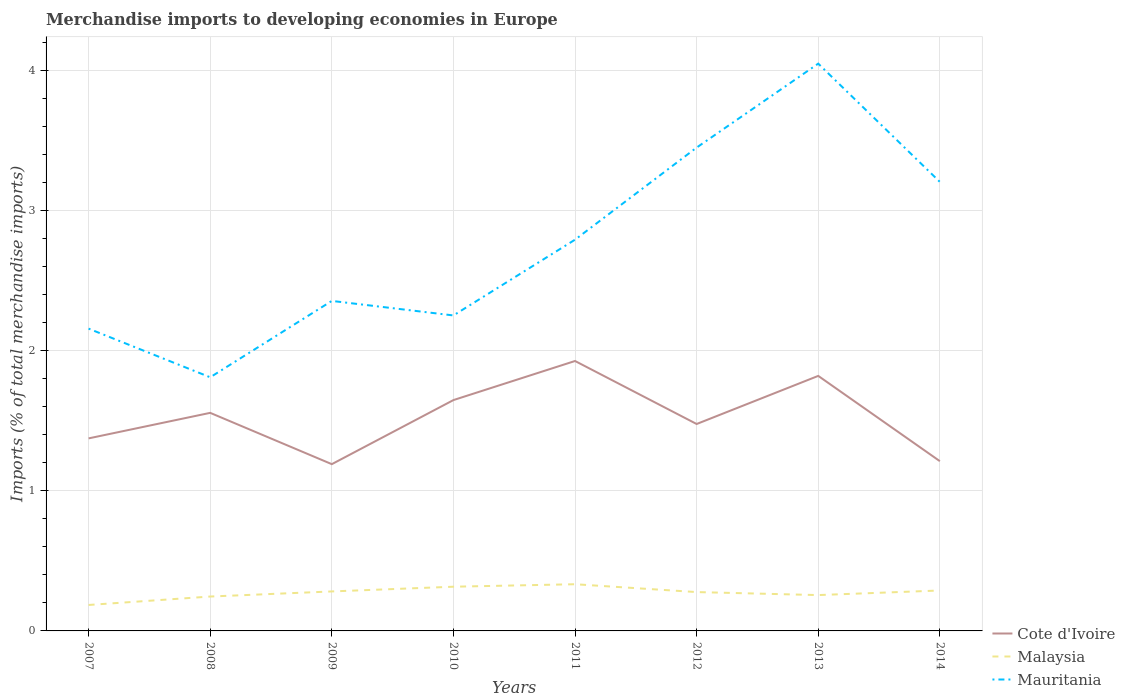Does the line corresponding to Mauritania intersect with the line corresponding to Malaysia?
Give a very brief answer. No. Across all years, what is the maximum percentage total merchandise imports in Cote d'Ivoire?
Offer a terse response. 1.19. What is the total percentage total merchandise imports in Malaysia in the graph?
Keep it short and to the point. -0.02. What is the difference between the highest and the second highest percentage total merchandise imports in Cote d'Ivoire?
Your answer should be compact. 0.74. What is the difference between the highest and the lowest percentage total merchandise imports in Cote d'Ivoire?
Keep it short and to the point. 4. How many lines are there?
Keep it short and to the point. 3. What is the difference between two consecutive major ticks on the Y-axis?
Offer a very short reply. 1. Where does the legend appear in the graph?
Ensure brevity in your answer.  Bottom right. What is the title of the graph?
Give a very brief answer. Merchandise imports to developing economies in Europe. What is the label or title of the X-axis?
Keep it short and to the point. Years. What is the label or title of the Y-axis?
Keep it short and to the point. Imports (% of total merchandise imports). What is the Imports (% of total merchandise imports) in Cote d'Ivoire in 2007?
Ensure brevity in your answer.  1.37. What is the Imports (% of total merchandise imports) in Malaysia in 2007?
Offer a terse response. 0.19. What is the Imports (% of total merchandise imports) in Mauritania in 2007?
Provide a succinct answer. 2.16. What is the Imports (% of total merchandise imports) in Cote d'Ivoire in 2008?
Your answer should be very brief. 1.56. What is the Imports (% of total merchandise imports) of Malaysia in 2008?
Give a very brief answer. 0.25. What is the Imports (% of total merchandise imports) of Mauritania in 2008?
Ensure brevity in your answer.  1.81. What is the Imports (% of total merchandise imports) of Cote d'Ivoire in 2009?
Make the answer very short. 1.19. What is the Imports (% of total merchandise imports) in Malaysia in 2009?
Provide a succinct answer. 0.28. What is the Imports (% of total merchandise imports) of Mauritania in 2009?
Your response must be concise. 2.36. What is the Imports (% of total merchandise imports) in Cote d'Ivoire in 2010?
Offer a very short reply. 1.65. What is the Imports (% of total merchandise imports) of Malaysia in 2010?
Offer a terse response. 0.32. What is the Imports (% of total merchandise imports) in Mauritania in 2010?
Your answer should be compact. 2.25. What is the Imports (% of total merchandise imports) in Cote d'Ivoire in 2011?
Your answer should be compact. 1.93. What is the Imports (% of total merchandise imports) in Malaysia in 2011?
Make the answer very short. 0.33. What is the Imports (% of total merchandise imports) in Mauritania in 2011?
Your answer should be very brief. 2.79. What is the Imports (% of total merchandise imports) in Cote d'Ivoire in 2012?
Keep it short and to the point. 1.48. What is the Imports (% of total merchandise imports) of Malaysia in 2012?
Provide a succinct answer. 0.28. What is the Imports (% of total merchandise imports) of Mauritania in 2012?
Your answer should be compact. 3.45. What is the Imports (% of total merchandise imports) in Cote d'Ivoire in 2013?
Make the answer very short. 1.82. What is the Imports (% of total merchandise imports) in Malaysia in 2013?
Provide a short and direct response. 0.26. What is the Imports (% of total merchandise imports) in Mauritania in 2013?
Your answer should be compact. 4.05. What is the Imports (% of total merchandise imports) of Cote d'Ivoire in 2014?
Your answer should be very brief. 1.21. What is the Imports (% of total merchandise imports) in Malaysia in 2014?
Ensure brevity in your answer.  0.29. What is the Imports (% of total merchandise imports) of Mauritania in 2014?
Your answer should be very brief. 3.21. Across all years, what is the maximum Imports (% of total merchandise imports) in Cote d'Ivoire?
Provide a succinct answer. 1.93. Across all years, what is the maximum Imports (% of total merchandise imports) in Malaysia?
Your answer should be very brief. 0.33. Across all years, what is the maximum Imports (% of total merchandise imports) of Mauritania?
Your response must be concise. 4.05. Across all years, what is the minimum Imports (% of total merchandise imports) of Cote d'Ivoire?
Offer a terse response. 1.19. Across all years, what is the minimum Imports (% of total merchandise imports) in Malaysia?
Your answer should be very brief. 0.19. Across all years, what is the minimum Imports (% of total merchandise imports) in Mauritania?
Your answer should be very brief. 1.81. What is the total Imports (% of total merchandise imports) in Cote d'Ivoire in the graph?
Your answer should be compact. 12.21. What is the total Imports (% of total merchandise imports) of Malaysia in the graph?
Your answer should be very brief. 2.18. What is the total Imports (% of total merchandise imports) in Mauritania in the graph?
Keep it short and to the point. 22.08. What is the difference between the Imports (% of total merchandise imports) of Cote d'Ivoire in 2007 and that in 2008?
Provide a short and direct response. -0.18. What is the difference between the Imports (% of total merchandise imports) of Malaysia in 2007 and that in 2008?
Your answer should be very brief. -0.06. What is the difference between the Imports (% of total merchandise imports) of Mauritania in 2007 and that in 2008?
Provide a short and direct response. 0.35. What is the difference between the Imports (% of total merchandise imports) in Cote d'Ivoire in 2007 and that in 2009?
Provide a succinct answer. 0.18. What is the difference between the Imports (% of total merchandise imports) in Malaysia in 2007 and that in 2009?
Make the answer very short. -0.1. What is the difference between the Imports (% of total merchandise imports) in Mauritania in 2007 and that in 2009?
Ensure brevity in your answer.  -0.2. What is the difference between the Imports (% of total merchandise imports) of Cote d'Ivoire in 2007 and that in 2010?
Give a very brief answer. -0.27. What is the difference between the Imports (% of total merchandise imports) of Malaysia in 2007 and that in 2010?
Offer a terse response. -0.13. What is the difference between the Imports (% of total merchandise imports) in Mauritania in 2007 and that in 2010?
Provide a succinct answer. -0.09. What is the difference between the Imports (% of total merchandise imports) in Cote d'Ivoire in 2007 and that in 2011?
Your answer should be very brief. -0.55. What is the difference between the Imports (% of total merchandise imports) in Malaysia in 2007 and that in 2011?
Give a very brief answer. -0.15. What is the difference between the Imports (% of total merchandise imports) of Mauritania in 2007 and that in 2011?
Your answer should be very brief. -0.64. What is the difference between the Imports (% of total merchandise imports) of Cote d'Ivoire in 2007 and that in 2012?
Offer a terse response. -0.1. What is the difference between the Imports (% of total merchandise imports) of Malaysia in 2007 and that in 2012?
Give a very brief answer. -0.09. What is the difference between the Imports (% of total merchandise imports) in Mauritania in 2007 and that in 2012?
Offer a very short reply. -1.29. What is the difference between the Imports (% of total merchandise imports) of Cote d'Ivoire in 2007 and that in 2013?
Give a very brief answer. -0.45. What is the difference between the Imports (% of total merchandise imports) in Malaysia in 2007 and that in 2013?
Keep it short and to the point. -0.07. What is the difference between the Imports (% of total merchandise imports) of Mauritania in 2007 and that in 2013?
Make the answer very short. -1.89. What is the difference between the Imports (% of total merchandise imports) of Cote d'Ivoire in 2007 and that in 2014?
Ensure brevity in your answer.  0.16. What is the difference between the Imports (% of total merchandise imports) in Malaysia in 2007 and that in 2014?
Ensure brevity in your answer.  -0.1. What is the difference between the Imports (% of total merchandise imports) of Mauritania in 2007 and that in 2014?
Offer a terse response. -1.05. What is the difference between the Imports (% of total merchandise imports) of Cote d'Ivoire in 2008 and that in 2009?
Ensure brevity in your answer.  0.37. What is the difference between the Imports (% of total merchandise imports) in Malaysia in 2008 and that in 2009?
Your answer should be compact. -0.04. What is the difference between the Imports (% of total merchandise imports) of Mauritania in 2008 and that in 2009?
Make the answer very short. -0.55. What is the difference between the Imports (% of total merchandise imports) in Cote d'Ivoire in 2008 and that in 2010?
Your response must be concise. -0.09. What is the difference between the Imports (% of total merchandise imports) in Malaysia in 2008 and that in 2010?
Make the answer very short. -0.07. What is the difference between the Imports (% of total merchandise imports) of Mauritania in 2008 and that in 2010?
Offer a very short reply. -0.44. What is the difference between the Imports (% of total merchandise imports) of Cote d'Ivoire in 2008 and that in 2011?
Offer a terse response. -0.37. What is the difference between the Imports (% of total merchandise imports) in Malaysia in 2008 and that in 2011?
Ensure brevity in your answer.  -0.09. What is the difference between the Imports (% of total merchandise imports) in Mauritania in 2008 and that in 2011?
Make the answer very short. -0.98. What is the difference between the Imports (% of total merchandise imports) in Cote d'Ivoire in 2008 and that in 2012?
Keep it short and to the point. 0.08. What is the difference between the Imports (% of total merchandise imports) of Malaysia in 2008 and that in 2012?
Your response must be concise. -0.03. What is the difference between the Imports (% of total merchandise imports) in Mauritania in 2008 and that in 2012?
Your answer should be very brief. -1.64. What is the difference between the Imports (% of total merchandise imports) of Cote d'Ivoire in 2008 and that in 2013?
Provide a succinct answer. -0.26. What is the difference between the Imports (% of total merchandise imports) in Malaysia in 2008 and that in 2013?
Make the answer very short. -0.01. What is the difference between the Imports (% of total merchandise imports) of Mauritania in 2008 and that in 2013?
Provide a succinct answer. -2.24. What is the difference between the Imports (% of total merchandise imports) in Cote d'Ivoire in 2008 and that in 2014?
Your answer should be very brief. 0.34. What is the difference between the Imports (% of total merchandise imports) in Malaysia in 2008 and that in 2014?
Make the answer very short. -0.04. What is the difference between the Imports (% of total merchandise imports) of Mauritania in 2008 and that in 2014?
Provide a short and direct response. -1.4. What is the difference between the Imports (% of total merchandise imports) of Cote d'Ivoire in 2009 and that in 2010?
Your answer should be very brief. -0.46. What is the difference between the Imports (% of total merchandise imports) in Malaysia in 2009 and that in 2010?
Offer a terse response. -0.03. What is the difference between the Imports (% of total merchandise imports) in Mauritania in 2009 and that in 2010?
Offer a very short reply. 0.1. What is the difference between the Imports (% of total merchandise imports) of Cote d'Ivoire in 2009 and that in 2011?
Offer a terse response. -0.74. What is the difference between the Imports (% of total merchandise imports) of Malaysia in 2009 and that in 2011?
Give a very brief answer. -0.05. What is the difference between the Imports (% of total merchandise imports) of Mauritania in 2009 and that in 2011?
Provide a short and direct response. -0.44. What is the difference between the Imports (% of total merchandise imports) of Cote d'Ivoire in 2009 and that in 2012?
Offer a terse response. -0.29. What is the difference between the Imports (% of total merchandise imports) in Malaysia in 2009 and that in 2012?
Offer a terse response. 0. What is the difference between the Imports (% of total merchandise imports) of Mauritania in 2009 and that in 2012?
Your response must be concise. -1.09. What is the difference between the Imports (% of total merchandise imports) of Cote d'Ivoire in 2009 and that in 2013?
Give a very brief answer. -0.63. What is the difference between the Imports (% of total merchandise imports) in Malaysia in 2009 and that in 2013?
Your response must be concise. 0.03. What is the difference between the Imports (% of total merchandise imports) of Mauritania in 2009 and that in 2013?
Provide a succinct answer. -1.69. What is the difference between the Imports (% of total merchandise imports) of Cote d'Ivoire in 2009 and that in 2014?
Provide a succinct answer. -0.02. What is the difference between the Imports (% of total merchandise imports) in Malaysia in 2009 and that in 2014?
Your answer should be very brief. -0.01. What is the difference between the Imports (% of total merchandise imports) of Mauritania in 2009 and that in 2014?
Keep it short and to the point. -0.85. What is the difference between the Imports (% of total merchandise imports) in Cote d'Ivoire in 2010 and that in 2011?
Keep it short and to the point. -0.28. What is the difference between the Imports (% of total merchandise imports) of Malaysia in 2010 and that in 2011?
Keep it short and to the point. -0.02. What is the difference between the Imports (% of total merchandise imports) in Mauritania in 2010 and that in 2011?
Offer a very short reply. -0.54. What is the difference between the Imports (% of total merchandise imports) of Cote d'Ivoire in 2010 and that in 2012?
Provide a short and direct response. 0.17. What is the difference between the Imports (% of total merchandise imports) of Malaysia in 2010 and that in 2012?
Give a very brief answer. 0.04. What is the difference between the Imports (% of total merchandise imports) of Mauritania in 2010 and that in 2012?
Your response must be concise. -1.2. What is the difference between the Imports (% of total merchandise imports) of Cote d'Ivoire in 2010 and that in 2013?
Your answer should be compact. -0.17. What is the difference between the Imports (% of total merchandise imports) of Malaysia in 2010 and that in 2013?
Your answer should be very brief. 0.06. What is the difference between the Imports (% of total merchandise imports) of Mauritania in 2010 and that in 2013?
Make the answer very short. -1.8. What is the difference between the Imports (% of total merchandise imports) in Cote d'Ivoire in 2010 and that in 2014?
Offer a very short reply. 0.44. What is the difference between the Imports (% of total merchandise imports) in Malaysia in 2010 and that in 2014?
Provide a short and direct response. 0.03. What is the difference between the Imports (% of total merchandise imports) of Mauritania in 2010 and that in 2014?
Ensure brevity in your answer.  -0.95. What is the difference between the Imports (% of total merchandise imports) of Cote d'Ivoire in 2011 and that in 2012?
Offer a very short reply. 0.45. What is the difference between the Imports (% of total merchandise imports) in Malaysia in 2011 and that in 2012?
Ensure brevity in your answer.  0.06. What is the difference between the Imports (% of total merchandise imports) of Mauritania in 2011 and that in 2012?
Your answer should be very brief. -0.66. What is the difference between the Imports (% of total merchandise imports) in Cote d'Ivoire in 2011 and that in 2013?
Offer a terse response. 0.11. What is the difference between the Imports (% of total merchandise imports) of Malaysia in 2011 and that in 2013?
Your answer should be very brief. 0.08. What is the difference between the Imports (% of total merchandise imports) of Mauritania in 2011 and that in 2013?
Keep it short and to the point. -1.26. What is the difference between the Imports (% of total merchandise imports) in Cote d'Ivoire in 2011 and that in 2014?
Give a very brief answer. 0.72. What is the difference between the Imports (% of total merchandise imports) in Malaysia in 2011 and that in 2014?
Offer a terse response. 0.04. What is the difference between the Imports (% of total merchandise imports) of Mauritania in 2011 and that in 2014?
Give a very brief answer. -0.41. What is the difference between the Imports (% of total merchandise imports) of Cote d'Ivoire in 2012 and that in 2013?
Offer a terse response. -0.34. What is the difference between the Imports (% of total merchandise imports) in Malaysia in 2012 and that in 2013?
Offer a terse response. 0.02. What is the difference between the Imports (% of total merchandise imports) of Mauritania in 2012 and that in 2013?
Provide a succinct answer. -0.6. What is the difference between the Imports (% of total merchandise imports) of Cote d'Ivoire in 2012 and that in 2014?
Ensure brevity in your answer.  0.27. What is the difference between the Imports (% of total merchandise imports) of Malaysia in 2012 and that in 2014?
Offer a very short reply. -0.01. What is the difference between the Imports (% of total merchandise imports) of Mauritania in 2012 and that in 2014?
Provide a succinct answer. 0.24. What is the difference between the Imports (% of total merchandise imports) of Cote d'Ivoire in 2013 and that in 2014?
Your answer should be very brief. 0.61. What is the difference between the Imports (% of total merchandise imports) in Malaysia in 2013 and that in 2014?
Keep it short and to the point. -0.03. What is the difference between the Imports (% of total merchandise imports) of Mauritania in 2013 and that in 2014?
Your answer should be compact. 0.84. What is the difference between the Imports (% of total merchandise imports) in Cote d'Ivoire in 2007 and the Imports (% of total merchandise imports) in Malaysia in 2008?
Offer a very short reply. 1.13. What is the difference between the Imports (% of total merchandise imports) of Cote d'Ivoire in 2007 and the Imports (% of total merchandise imports) of Mauritania in 2008?
Your response must be concise. -0.44. What is the difference between the Imports (% of total merchandise imports) of Malaysia in 2007 and the Imports (% of total merchandise imports) of Mauritania in 2008?
Offer a very short reply. -1.63. What is the difference between the Imports (% of total merchandise imports) in Cote d'Ivoire in 2007 and the Imports (% of total merchandise imports) in Malaysia in 2009?
Make the answer very short. 1.09. What is the difference between the Imports (% of total merchandise imports) in Cote d'Ivoire in 2007 and the Imports (% of total merchandise imports) in Mauritania in 2009?
Your answer should be very brief. -0.98. What is the difference between the Imports (% of total merchandise imports) of Malaysia in 2007 and the Imports (% of total merchandise imports) of Mauritania in 2009?
Provide a short and direct response. -2.17. What is the difference between the Imports (% of total merchandise imports) of Cote d'Ivoire in 2007 and the Imports (% of total merchandise imports) of Malaysia in 2010?
Ensure brevity in your answer.  1.06. What is the difference between the Imports (% of total merchandise imports) of Cote d'Ivoire in 2007 and the Imports (% of total merchandise imports) of Mauritania in 2010?
Your answer should be compact. -0.88. What is the difference between the Imports (% of total merchandise imports) in Malaysia in 2007 and the Imports (% of total merchandise imports) in Mauritania in 2010?
Make the answer very short. -2.07. What is the difference between the Imports (% of total merchandise imports) in Cote d'Ivoire in 2007 and the Imports (% of total merchandise imports) in Malaysia in 2011?
Give a very brief answer. 1.04. What is the difference between the Imports (% of total merchandise imports) in Cote d'Ivoire in 2007 and the Imports (% of total merchandise imports) in Mauritania in 2011?
Keep it short and to the point. -1.42. What is the difference between the Imports (% of total merchandise imports) of Malaysia in 2007 and the Imports (% of total merchandise imports) of Mauritania in 2011?
Make the answer very short. -2.61. What is the difference between the Imports (% of total merchandise imports) in Cote d'Ivoire in 2007 and the Imports (% of total merchandise imports) in Malaysia in 2012?
Ensure brevity in your answer.  1.1. What is the difference between the Imports (% of total merchandise imports) in Cote d'Ivoire in 2007 and the Imports (% of total merchandise imports) in Mauritania in 2012?
Your answer should be compact. -2.08. What is the difference between the Imports (% of total merchandise imports) in Malaysia in 2007 and the Imports (% of total merchandise imports) in Mauritania in 2012?
Provide a succinct answer. -3.27. What is the difference between the Imports (% of total merchandise imports) in Cote d'Ivoire in 2007 and the Imports (% of total merchandise imports) in Malaysia in 2013?
Offer a terse response. 1.12. What is the difference between the Imports (% of total merchandise imports) in Cote d'Ivoire in 2007 and the Imports (% of total merchandise imports) in Mauritania in 2013?
Offer a terse response. -2.68. What is the difference between the Imports (% of total merchandise imports) of Malaysia in 2007 and the Imports (% of total merchandise imports) of Mauritania in 2013?
Your answer should be very brief. -3.87. What is the difference between the Imports (% of total merchandise imports) in Cote d'Ivoire in 2007 and the Imports (% of total merchandise imports) in Malaysia in 2014?
Provide a succinct answer. 1.09. What is the difference between the Imports (% of total merchandise imports) of Cote d'Ivoire in 2007 and the Imports (% of total merchandise imports) of Mauritania in 2014?
Your response must be concise. -1.83. What is the difference between the Imports (% of total merchandise imports) in Malaysia in 2007 and the Imports (% of total merchandise imports) in Mauritania in 2014?
Your answer should be very brief. -3.02. What is the difference between the Imports (% of total merchandise imports) in Cote d'Ivoire in 2008 and the Imports (% of total merchandise imports) in Malaysia in 2009?
Keep it short and to the point. 1.28. What is the difference between the Imports (% of total merchandise imports) in Cote d'Ivoire in 2008 and the Imports (% of total merchandise imports) in Mauritania in 2009?
Offer a very short reply. -0.8. What is the difference between the Imports (% of total merchandise imports) in Malaysia in 2008 and the Imports (% of total merchandise imports) in Mauritania in 2009?
Keep it short and to the point. -2.11. What is the difference between the Imports (% of total merchandise imports) in Cote d'Ivoire in 2008 and the Imports (% of total merchandise imports) in Malaysia in 2010?
Your response must be concise. 1.24. What is the difference between the Imports (% of total merchandise imports) in Cote d'Ivoire in 2008 and the Imports (% of total merchandise imports) in Mauritania in 2010?
Give a very brief answer. -0.7. What is the difference between the Imports (% of total merchandise imports) in Malaysia in 2008 and the Imports (% of total merchandise imports) in Mauritania in 2010?
Give a very brief answer. -2.01. What is the difference between the Imports (% of total merchandise imports) in Cote d'Ivoire in 2008 and the Imports (% of total merchandise imports) in Malaysia in 2011?
Offer a very short reply. 1.22. What is the difference between the Imports (% of total merchandise imports) of Cote d'Ivoire in 2008 and the Imports (% of total merchandise imports) of Mauritania in 2011?
Give a very brief answer. -1.24. What is the difference between the Imports (% of total merchandise imports) of Malaysia in 2008 and the Imports (% of total merchandise imports) of Mauritania in 2011?
Ensure brevity in your answer.  -2.55. What is the difference between the Imports (% of total merchandise imports) of Cote d'Ivoire in 2008 and the Imports (% of total merchandise imports) of Malaysia in 2012?
Ensure brevity in your answer.  1.28. What is the difference between the Imports (% of total merchandise imports) in Cote d'Ivoire in 2008 and the Imports (% of total merchandise imports) in Mauritania in 2012?
Provide a short and direct response. -1.89. What is the difference between the Imports (% of total merchandise imports) of Malaysia in 2008 and the Imports (% of total merchandise imports) of Mauritania in 2012?
Your answer should be very brief. -3.21. What is the difference between the Imports (% of total merchandise imports) of Cote d'Ivoire in 2008 and the Imports (% of total merchandise imports) of Malaysia in 2013?
Your answer should be very brief. 1.3. What is the difference between the Imports (% of total merchandise imports) of Cote d'Ivoire in 2008 and the Imports (% of total merchandise imports) of Mauritania in 2013?
Make the answer very short. -2.49. What is the difference between the Imports (% of total merchandise imports) in Malaysia in 2008 and the Imports (% of total merchandise imports) in Mauritania in 2013?
Provide a succinct answer. -3.8. What is the difference between the Imports (% of total merchandise imports) in Cote d'Ivoire in 2008 and the Imports (% of total merchandise imports) in Malaysia in 2014?
Your answer should be compact. 1.27. What is the difference between the Imports (% of total merchandise imports) of Cote d'Ivoire in 2008 and the Imports (% of total merchandise imports) of Mauritania in 2014?
Offer a very short reply. -1.65. What is the difference between the Imports (% of total merchandise imports) of Malaysia in 2008 and the Imports (% of total merchandise imports) of Mauritania in 2014?
Ensure brevity in your answer.  -2.96. What is the difference between the Imports (% of total merchandise imports) in Cote d'Ivoire in 2009 and the Imports (% of total merchandise imports) in Mauritania in 2010?
Your response must be concise. -1.06. What is the difference between the Imports (% of total merchandise imports) of Malaysia in 2009 and the Imports (% of total merchandise imports) of Mauritania in 2010?
Offer a terse response. -1.97. What is the difference between the Imports (% of total merchandise imports) in Cote d'Ivoire in 2009 and the Imports (% of total merchandise imports) in Malaysia in 2011?
Offer a terse response. 0.86. What is the difference between the Imports (% of total merchandise imports) in Cote d'Ivoire in 2009 and the Imports (% of total merchandise imports) in Mauritania in 2011?
Provide a succinct answer. -1.6. What is the difference between the Imports (% of total merchandise imports) in Malaysia in 2009 and the Imports (% of total merchandise imports) in Mauritania in 2011?
Provide a short and direct response. -2.51. What is the difference between the Imports (% of total merchandise imports) of Cote d'Ivoire in 2009 and the Imports (% of total merchandise imports) of Malaysia in 2012?
Provide a short and direct response. 0.91. What is the difference between the Imports (% of total merchandise imports) of Cote d'Ivoire in 2009 and the Imports (% of total merchandise imports) of Mauritania in 2012?
Provide a short and direct response. -2.26. What is the difference between the Imports (% of total merchandise imports) of Malaysia in 2009 and the Imports (% of total merchandise imports) of Mauritania in 2012?
Ensure brevity in your answer.  -3.17. What is the difference between the Imports (% of total merchandise imports) of Cote d'Ivoire in 2009 and the Imports (% of total merchandise imports) of Malaysia in 2013?
Provide a short and direct response. 0.93. What is the difference between the Imports (% of total merchandise imports) in Cote d'Ivoire in 2009 and the Imports (% of total merchandise imports) in Mauritania in 2013?
Provide a short and direct response. -2.86. What is the difference between the Imports (% of total merchandise imports) in Malaysia in 2009 and the Imports (% of total merchandise imports) in Mauritania in 2013?
Offer a terse response. -3.77. What is the difference between the Imports (% of total merchandise imports) in Cote d'Ivoire in 2009 and the Imports (% of total merchandise imports) in Malaysia in 2014?
Make the answer very short. 0.9. What is the difference between the Imports (% of total merchandise imports) of Cote d'Ivoire in 2009 and the Imports (% of total merchandise imports) of Mauritania in 2014?
Your answer should be very brief. -2.02. What is the difference between the Imports (% of total merchandise imports) of Malaysia in 2009 and the Imports (% of total merchandise imports) of Mauritania in 2014?
Make the answer very short. -2.92. What is the difference between the Imports (% of total merchandise imports) of Cote d'Ivoire in 2010 and the Imports (% of total merchandise imports) of Malaysia in 2011?
Your response must be concise. 1.31. What is the difference between the Imports (% of total merchandise imports) of Cote d'Ivoire in 2010 and the Imports (% of total merchandise imports) of Mauritania in 2011?
Your answer should be compact. -1.15. What is the difference between the Imports (% of total merchandise imports) of Malaysia in 2010 and the Imports (% of total merchandise imports) of Mauritania in 2011?
Provide a short and direct response. -2.48. What is the difference between the Imports (% of total merchandise imports) of Cote d'Ivoire in 2010 and the Imports (% of total merchandise imports) of Malaysia in 2012?
Your response must be concise. 1.37. What is the difference between the Imports (% of total merchandise imports) of Cote d'Ivoire in 2010 and the Imports (% of total merchandise imports) of Mauritania in 2012?
Offer a very short reply. -1.8. What is the difference between the Imports (% of total merchandise imports) in Malaysia in 2010 and the Imports (% of total merchandise imports) in Mauritania in 2012?
Provide a short and direct response. -3.14. What is the difference between the Imports (% of total merchandise imports) in Cote d'Ivoire in 2010 and the Imports (% of total merchandise imports) in Malaysia in 2013?
Offer a terse response. 1.39. What is the difference between the Imports (% of total merchandise imports) of Cote d'Ivoire in 2010 and the Imports (% of total merchandise imports) of Mauritania in 2013?
Your answer should be compact. -2.4. What is the difference between the Imports (% of total merchandise imports) of Malaysia in 2010 and the Imports (% of total merchandise imports) of Mauritania in 2013?
Offer a very short reply. -3.73. What is the difference between the Imports (% of total merchandise imports) of Cote d'Ivoire in 2010 and the Imports (% of total merchandise imports) of Malaysia in 2014?
Your answer should be compact. 1.36. What is the difference between the Imports (% of total merchandise imports) in Cote d'Ivoire in 2010 and the Imports (% of total merchandise imports) in Mauritania in 2014?
Offer a very short reply. -1.56. What is the difference between the Imports (% of total merchandise imports) in Malaysia in 2010 and the Imports (% of total merchandise imports) in Mauritania in 2014?
Keep it short and to the point. -2.89. What is the difference between the Imports (% of total merchandise imports) of Cote d'Ivoire in 2011 and the Imports (% of total merchandise imports) of Malaysia in 2012?
Ensure brevity in your answer.  1.65. What is the difference between the Imports (% of total merchandise imports) in Cote d'Ivoire in 2011 and the Imports (% of total merchandise imports) in Mauritania in 2012?
Offer a terse response. -1.52. What is the difference between the Imports (% of total merchandise imports) in Malaysia in 2011 and the Imports (% of total merchandise imports) in Mauritania in 2012?
Make the answer very short. -3.12. What is the difference between the Imports (% of total merchandise imports) in Cote d'Ivoire in 2011 and the Imports (% of total merchandise imports) in Malaysia in 2013?
Give a very brief answer. 1.67. What is the difference between the Imports (% of total merchandise imports) of Cote d'Ivoire in 2011 and the Imports (% of total merchandise imports) of Mauritania in 2013?
Your response must be concise. -2.12. What is the difference between the Imports (% of total merchandise imports) of Malaysia in 2011 and the Imports (% of total merchandise imports) of Mauritania in 2013?
Provide a short and direct response. -3.72. What is the difference between the Imports (% of total merchandise imports) of Cote d'Ivoire in 2011 and the Imports (% of total merchandise imports) of Malaysia in 2014?
Your answer should be compact. 1.64. What is the difference between the Imports (% of total merchandise imports) in Cote d'Ivoire in 2011 and the Imports (% of total merchandise imports) in Mauritania in 2014?
Your answer should be very brief. -1.28. What is the difference between the Imports (% of total merchandise imports) of Malaysia in 2011 and the Imports (% of total merchandise imports) of Mauritania in 2014?
Offer a terse response. -2.87. What is the difference between the Imports (% of total merchandise imports) of Cote d'Ivoire in 2012 and the Imports (% of total merchandise imports) of Malaysia in 2013?
Your answer should be compact. 1.22. What is the difference between the Imports (% of total merchandise imports) of Cote d'Ivoire in 2012 and the Imports (% of total merchandise imports) of Mauritania in 2013?
Offer a very short reply. -2.57. What is the difference between the Imports (% of total merchandise imports) of Malaysia in 2012 and the Imports (% of total merchandise imports) of Mauritania in 2013?
Keep it short and to the point. -3.77. What is the difference between the Imports (% of total merchandise imports) in Cote d'Ivoire in 2012 and the Imports (% of total merchandise imports) in Malaysia in 2014?
Your answer should be compact. 1.19. What is the difference between the Imports (% of total merchandise imports) in Cote d'Ivoire in 2012 and the Imports (% of total merchandise imports) in Mauritania in 2014?
Offer a terse response. -1.73. What is the difference between the Imports (% of total merchandise imports) in Malaysia in 2012 and the Imports (% of total merchandise imports) in Mauritania in 2014?
Provide a short and direct response. -2.93. What is the difference between the Imports (% of total merchandise imports) of Cote d'Ivoire in 2013 and the Imports (% of total merchandise imports) of Malaysia in 2014?
Offer a very short reply. 1.53. What is the difference between the Imports (% of total merchandise imports) of Cote d'Ivoire in 2013 and the Imports (% of total merchandise imports) of Mauritania in 2014?
Your response must be concise. -1.39. What is the difference between the Imports (% of total merchandise imports) of Malaysia in 2013 and the Imports (% of total merchandise imports) of Mauritania in 2014?
Keep it short and to the point. -2.95. What is the average Imports (% of total merchandise imports) of Cote d'Ivoire per year?
Give a very brief answer. 1.53. What is the average Imports (% of total merchandise imports) in Malaysia per year?
Offer a terse response. 0.27. What is the average Imports (% of total merchandise imports) in Mauritania per year?
Your answer should be very brief. 2.76. In the year 2007, what is the difference between the Imports (% of total merchandise imports) in Cote d'Ivoire and Imports (% of total merchandise imports) in Malaysia?
Offer a very short reply. 1.19. In the year 2007, what is the difference between the Imports (% of total merchandise imports) of Cote d'Ivoire and Imports (% of total merchandise imports) of Mauritania?
Provide a succinct answer. -0.78. In the year 2007, what is the difference between the Imports (% of total merchandise imports) in Malaysia and Imports (% of total merchandise imports) in Mauritania?
Provide a succinct answer. -1.97. In the year 2008, what is the difference between the Imports (% of total merchandise imports) in Cote d'Ivoire and Imports (% of total merchandise imports) in Malaysia?
Keep it short and to the point. 1.31. In the year 2008, what is the difference between the Imports (% of total merchandise imports) of Cote d'Ivoire and Imports (% of total merchandise imports) of Mauritania?
Ensure brevity in your answer.  -0.25. In the year 2008, what is the difference between the Imports (% of total merchandise imports) in Malaysia and Imports (% of total merchandise imports) in Mauritania?
Your answer should be very brief. -1.57. In the year 2009, what is the difference between the Imports (% of total merchandise imports) of Cote d'Ivoire and Imports (% of total merchandise imports) of Malaysia?
Offer a terse response. 0.91. In the year 2009, what is the difference between the Imports (% of total merchandise imports) of Cote d'Ivoire and Imports (% of total merchandise imports) of Mauritania?
Give a very brief answer. -1.17. In the year 2009, what is the difference between the Imports (% of total merchandise imports) in Malaysia and Imports (% of total merchandise imports) in Mauritania?
Provide a short and direct response. -2.07. In the year 2010, what is the difference between the Imports (% of total merchandise imports) of Cote d'Ivoire and Imports (% of total merchandise imports) of Malaysia?
Provide a short and direct response. 1.33. In the year 2010, what is the difference between the Imports (% of total merchandise imports) in Cote d'Ivoire and Imports (% of total merchandise imports) in Mauritania?
Provide a short and direct response. -0.6. In the year 2010, what is the difference between the Imports (% of total merchandise imports) in Malaysia and Imports (% of total merchandise imports) in Mauritania?
Your answer should be very brief. -1.94. In the year 2011, what is the difference between the Imports (% of total merchandise imports) of Cote d'Ivoire and Imports (% of total merchandise imports) of Malaysia?
Provide a short and direct response. 1.59. In the year 2011, what is the difference between the Imports (% of total merchandise imports) of Cote d'Ivoire and Imports (% of total merchandise imports) of Mauritania?
Offer a very short reply. -0.87. In the year 2011, what is the difference between the Imports (% of total merchandise imports) of Malaysia and Imports (% of total merchandise imports) of Mauritania?
Your response must be concise. -2.46. In the year 2012, what is the difference between the Imports (% of total merchandise imports) of Cote d'Ivoire and Imports (% of total merchandise imports) of Malaysia?
Make the answer very short. 1.2. In the year 2012, what is the difference between the Imports (% of total merchandise imports) of Cote d'Ivoire and Imports (% of total merchandise imports) of Mauritania?
Offer a very short reply. -1.97. In the year 2012, what is the difference between the Imports (% of total merchandise imports) of Malaysia and Imports (% of total merchandise imports) of Mauritania?
Ensure brevity in your answer.  -3.17. In the year 2013, what is the difference between the Imports (% of total merchandise imports) of Cote d'Ivoire and Imports (% of total merchandise imports) of Malaysia?
Offer a terse response. 1.56. In the year 2013, what is the difference between the Imports (% of total merchandise imports) in Cote d'Ivoire and Imports (% of total merchandise imports) in Mauritania?
Your answer should be compact. -2.23. In the year 2013, what is the difference between the Imports (% of total merchandise imports) in Malaysia and Imports (% of total merchandise imports) in Mauritania?
Your answer should be very brief. -3.79. In the year 2014, what is the difference between the Imports (% of total merchandise imports) in Cote d'Ivoire and Imports (% of total merchandise imports) in Malaysia?
Provide a succinct answer. 0.92. In the year 2014, what is the difference between the Imports (% of total merchandise imports) in Cote d'Ivoire and Imports (% of total merchandise imports) in Mauritania?
Provide a short and direct response. -1.99. In the year 2014, what is the difference between the Imports (% of total merchandise imports) of Malaysia and Imports (% of total merchandise imports) of Mauritania?
Your answer should be compact. -2.92. What is the ratio of the Imports (% of total merchandise imports) of Cote d'Ivoire in 2007 to that in 2008?
Your answer should be very brief. 0.88. What is the ratio of the Imports (% of total merchandise imports) of Malaysia in 2007 to that in 2008?
Give a very brief answer. 0.75. What is the ratio of the Imports (% of total merchandise imports) of Mauritania in 2007 to that in 2008?
Offer a very short reply. 1.19. What is the ratio of the Imports (% of total merchandise imports) of Cote d'Ivoire in 2007 to that in 2009?
Offer a very short reply. 1.15. What is the ratio of the Imports (% of total merchandise imports) in Malaysia in 2007 to that in 2009?
Keep it short and to the point. 0.66. What is the ratio of the Imports (% of total merchandise imports) of Mauritania in 2007 to that in 2009?
Make the answer very short. 0.92. What is the ratio of the Imports (% of total merchandise imports) in Cote d'Ivoire in 2007 to that in 2010?
Your answer should be very brief. 0.83. What is the ratio of the Imports (% of total merchandise imports) of Malaysia in 2007 to that in 2010?
Ensure brevity in your answer.  0.59. What is the ratio of the Imports (% of total merchandise imports) of Mauritania in 2007 to that in 2010?
Provide a short and direct response. 0.96. What is the ratio of the Imports (% of total merchandise imports) in Cote d'Ivoire in 2007 to that in 2011?
Offer a terse response. 0.71. What is the ratio of the Imports (% of total merchandise imports) in Malaysia in 2007 to that in 2011?
Make the answer very short. 0.56. What is the ratio of the Imports (% of total merchandise imports) of Mauritania in 2007 to that in 2011?
Make the answer very short. 0.77. What is the ratio of the Imports (% of total merchandise imports) of Cote d'Ivoire in 2007 to that in 2012?
Keep it short and to the point. 0.93. What is the ratio of the Imports (% of total merchandise imports) of Malaysia in 2007 to that in 2012?
Provide a succinct answer. 0.67. What is the ratio of the Imports (% of total merchandise imports) in Mauritania in 2007 to that in 2012?
Offer a very short reply. 0.63. What is the ratio of the Imports (% of total merchandise imports) of Cote d'Ivoire in 2007 to that in 2013?
Ensure brevity in your answer.  0.76. What is the ratio of the Imports (% of total merchandise imports) in Malaysia in 2007 to that in 2013?
Your response must be concise. 0.72. What is the ratio of the Imports (% of total merchandise imports) in Mauritania in 2007 to that in 2013?
Give a very brief answer. 0.53. What is the ratio of the Imports (% of total merchandise imports) of Cote d'Ivoire in 2007 to that in 2014?
Provide a short and direct response. 1.13. What is the ratio of the Imports (% of total merchandise imports) in Malaysia in 2007 to that in 2014?
Your answer should be very brief. 0.64. What is the ratio of the Imports (% of total merchandise imports) of Mauritania in 2007 to that in 2014?
Offer a terse response. 0.67. What is the ratio of the Imports (% of total merchandise imports) in Cote d'Ivoire in 2008 to that in 2009?
Keep it short and to the point. 1.31. What is the ratio of the Imports (% of total merchandise imports) of Malaysia in 2008 to that in 2009?
Your answer should be compact. 0.87. What is the ratio of the Imports (% of total merchandise imports) in Mauritania in 2008 to that in 2009?
Your answer should be compact. 0.77. What is the ratio of the Imports (% of total merchandise imports) in Cote d'Ivoire in 2008 to that in 2010?
Offer a terse response. 0.94. What is the ratio of the Imports (% of total merchandise imports) in Malaysia in 2008 to that in 2010?
Your answer should be very brief. 0.78. What is the ratio of the Imports (% of total merchandise imports) of Mauritania in 2008 to that in 2010?
Provide a short and direct response. 0.8. What is the ratio of the Imports (% of total merchandise imports) in Cote d'Ivoire in 2008 to that in 2011?
Give a very brief answer. 0.81. What is the ratio of the Imports (% of total merchandise imports) in Malaysia in 2008 to that in 2011?
Keep it short and to the point. 0.74. What is the ratio of the Imports (% of total merchandise imports) in Mauritania in 2008 to that in 2011?
Ensure brevity in your answer.  0.65. What is the ratio of the Imports (% of total merchandise imports) of Cote d'Ivoire in 2008 to that in 2012?
Ensure brevity in your answer.  1.05. What is the ratio of the Imports (% of total merchandise imports) in Malaysia in 2008 to that in 2012?
Keep it short and to the point. 0.89. What is the ratio of the Imports (% of total merchandise imports) of Mauritania in 2008 to that in 2012?
Your answer should be very brief. 0.52. What is the ratio of the Imports (% of total merchandise imports) of Cote d'Ivoire in 2008 to that in 2013?
Offer a terse response. 0.86. What is the ratio of the Imports (% of total merchandise imports) of Malaysia in 2008 to that in 2013?
Keep it short and to the point. 0.96. What is the ratio of the Imports (% of total merchandise imports) in Mauritania in 2008 to that in 2013?
Make the answer very short. 0.45. What is the ratio of the Imports (% of total merchandise imports) of Cote d'Ivoire in 2008 to that in 2014?
Your answer should be compact. 1.28. What is the ratio of the Imports (% of total merchandise imports) of Malaysia in 2008 to that in 2014?
Make the answer very short. 0.85. What is the ratio of the Imports (% of total merchandise imports) of Mauritania in 2008 to that in 2014?
Your answer should be compact. 0.56. What is the ratio of the Imports (% of total merchandise imports) in Cote d'Ivoire in 2009 to that in 2010?
Offer a terse response. 0.72. What is the ratio of the Imports (% of total merchandise imports) in Malaysia in 2009 to that in 2010?
Your answer should be compact. 0.89. What is the ratio of the Imports (% of total merchandise imports) in Mauritania in 2009 to that in 2010?
Keep it short and to the point. 1.05. What is the ratio of the Imports (% of total merchandise imports) in Cote d'Ivoire in 2009 to that in 2011?
Provide a succinct answer. 0.62. What is the ratio of the Imports (% of total merchandise imports) in Malaysia in 2009 to that in 2011?
Make the answer very short. 0.85. What is the ratio of the Imports (% of total merchandise imports) in Mauritania in 2009 to that in 2011?
Your response must be concise. 0.84. What is the ratio of the Imports (% of total merchandise imports) in Cote d'Ivoire in 2009 to that in 2012?
Offer a very short reply. 0.81. What is the ratio of the Imports (% of total merchandise imports) in Malaysia in 2009 to that in 2012?
Provide a short and direct response. 1.02. What is the ratio of the Imports (% of total merchandise imports) of Mauritania in 2009 to that in 2012?
Your response must be concise. 0.68. What is the ratio of the Imports (% of total merchandise imports) in Cote d'Ivoire in 2009 to that in 2013?
Give a very brief answer. 0.65. What is the ratio of the Imports (% of total merchandise imports) in Malaysia in 2009 to that in 2013?
Make the answer very short. 1.1. What is the ratio of the Imports (% of total merchandise imports) of Mauritania in 2009 to that in 2013?
Provide a succinct answer. 0.58. What is the ratio of the Imports (% of total merchandise imports) in Cote d'Ivoire in 2009 to that in 2014?
Provide a short and direct response. 0.98. What is the ratio of the Imports (% of total merchandise imports) of Malaysia in 2009 to that in 2014?
Ensure brevity in your answer.  0.98. What is the ratio of the Imports (% of total merchandise imports) in Mauritania in 2009 to that in 2014?
Offer a very short reply. 0.73. What is the ratio of the Imports (% of total merchandise imports) in Cote d'Ivoire in 2010 to that in 2011?
Make the answer very short. 0.86. What is the ratio of the Imports (% of total merchandise imports) of Malaysia in 2010 to that in 2011?
Offer a very short reply. 0.95. What is the ratio of the Imports (% of total merchandise imports) of Mauritania in 2010 to that in 2011?
Your answer should be compact. 0.81. What is the ratio of the Imports (% of total merchandise imports) in Cote d'Ivoire in 2010 to that in 2012?
Your answer should be very brief. 1.12. What is the ratio of the Imports (% of total merchandise imports) of Malaysia in 2010 to that in 2012?
Ensure brevity in your answer.  1.14. What is the ratio of the Imports (% of total merchandise imports) in Mauritania in 2010 to that in 2012?
Your response must be concise. 0.65. What is the ratio of the Imports (% of total merchandise imports) of Cote d'Ivoire in 2010 to that in 2013?
Provide a short and direct response. 0.91. What is the ratio of the Imports (% of total merchandise imports) in Malaysia in 2010 to that in 2013?
Offer a very short reply. 1.23. What is the ratio of the Imports (% of total merchandise imports) of Mauritania in 2010 to that in 2013?
Ensure brevity in your answer.  0.56. What is the ratio of the Imports (% of total merchandise imports) of Cote d'Ivoire in 2010 to that in 2014?
Your answer should be very brief. 1.36. What is the ratio of the Imports (% of total merchandise imports) of Malaysia in 2010 to that in 2014?
Provide a short and direct response. 1.09. What is the ratio of the Imports (% of total merchandise imports) of Mauritania in 2010 to that in 2014?
Keep it short and to the point. 0.7. What is the ratio of the Imports (% of total merchandise imports) of Cote d'Ivoire in 2011 to that in 2012?
Provide a short and direct response. 1.3. What is the ratio of the Imports (% of total merchandise imports) in Malaysia in 2011 to that in 2012?
Offer a terse response. 1.2. What is the ratio of the Imports (% of total merchandise imports) in Mauritania in 2011 to that in 2012?
Your response must be concise. 0.81. What is the ratio of the Imports (% of total merchandise imports) of Cote d'Ivoire in 2011 to that in 2013?
Your answer should be very brief. 1.06. What is the ratio of the Imports (% of total merchandise imports) in Malaysia in 2011 to that in 2013?
Provide a short and direct response. 1.3. What is the ratio of the Imports (% of total merchandise imports) of Mauritania in 2011 to that in 2013?
Your answer should be compact. 0.69. What is the ratio of the Imports (% of total merchandise imports) of Cote d'Ivoire in 2011 to that in 2014?
Offer a very short reply. 1.59. What is the ratio of the Imports (% of total merchandise imports) in Malaysia in 2011 to that in 2014?
Provide a short and direct response. 1.16. What is the ratio of the Imports (% of total merchandise imports) in Mauritania in 2011 to that in 2014?
Provide a short and direct response. 0.87. What is the ratio of the Imports (% of total merchandise imports) of Cote d'Ivoire in 2012 to that in 2013?
Provide a succinct answer. 0.81. What is the ratio of the Imports (% of total merchandise imports) of Malaysia in 2012 to that in 2013?
Offer a very short reply. 1.08. What is the ratio of the Imports (% of total merchandise imports) in Mauritania in 2012 to that in 2013?
Your answer should be compact. 0.85. What is the ratio of the Imports (% of total merchandise imports) in Cote d'Ivoire in 2012 to that in 2014?
Offer a very short reply. 1.22. What is the ratio of the Imports (% of total merchandise imports) in Malaysia in 2012 to that in 2014?
Ensure brevity in your answer.  0.96. What is the ratio of the Imports (% of total merchandise imports) in Mauritania in 2012 to that in 2014?
Offer a terse response. 1.08. What is the ratio of the Imports (% of total merchandise imports) in Cote d'Ivoire in 2013 to that in 2014?
Offer a terse response. 1.5. What is the ratio of the Imports (% of total merchandise imports) in Malaysia in 2013 to that in 2014?
Keep it short and to the point. 0.89. What is the ratio of the Imports (% of total merchandise imports) in Mauritania in 2013 to that in 2014?
Provide a short and direct response. 1.26. What is the difference between the highest and the second highest Imports (% of total merchandise imports) of Cote d'Ivoire?
Offer a terse response. 0.11. What is the difference between the highest and the second highest Imports (% of total merchandise imports) in Malaysia?
Make the answer very short. 0.02. What is the difference between the highest and the second highest Imports (% of total merchandise imports) in Mauritania?
Make the answer very short. 0.6. What is the difference between the highest and the lowest Imports (% of total merchandise imports) of Cote d'Ivoire?
Your answer should be very brief. 0.74. What is the difference between the highest and the lowest Imports (% of total merchandise imports) in Malaysia?
Keep it short and to the point. 0.15. What is the difference between the highest and the lowest Imports (% of total merchandise imports) of Mauritania?
Provide a short and direct response. 2.24. 